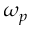<formula> <loc_0><loc_0><loc_500><loc_500>\omega _ { p }</formula> 